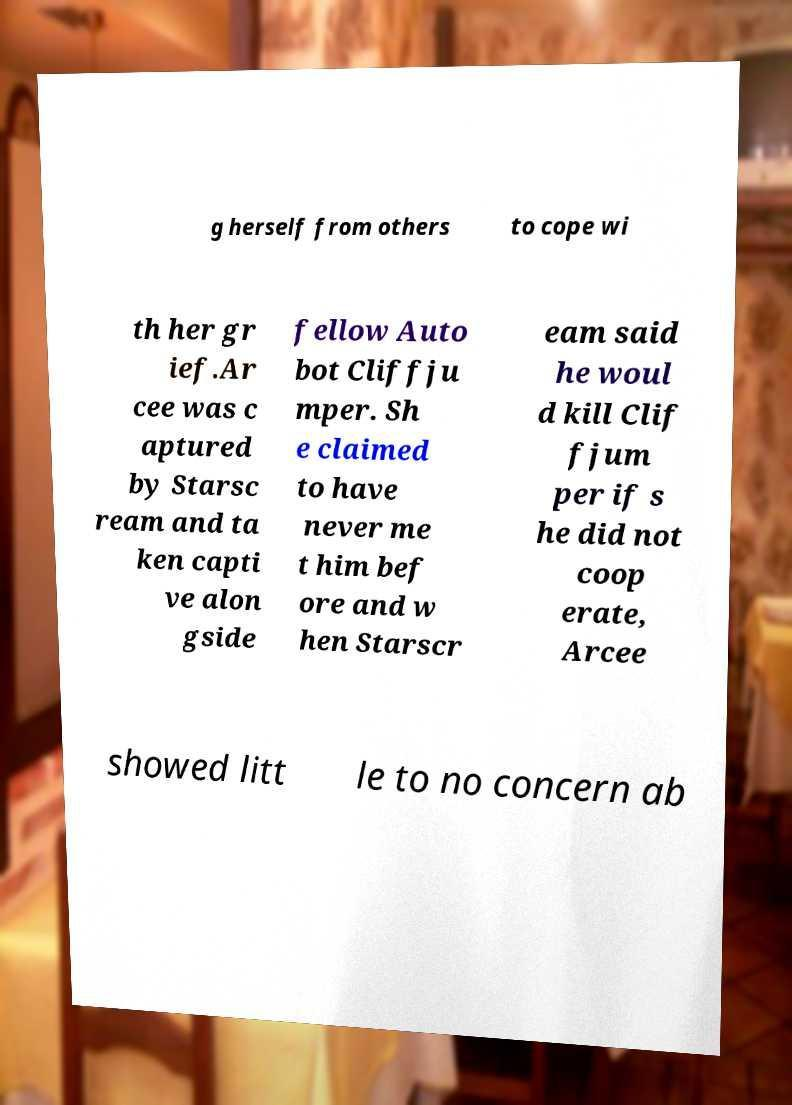Please read and relay the text visible in this image. What does it say? g herself from others to cope wi th her gr ief.Ar cee was c aptured by Starsc ream and ta ken capti ve alon gside fellow Auto bot Cliffju mper. Sh e claimed to have never me t him bef ore and w hen Starscr eam said he woul d kill Clif fjum per if s he did not coop erate, Arcee showed litt le to no concern ab 